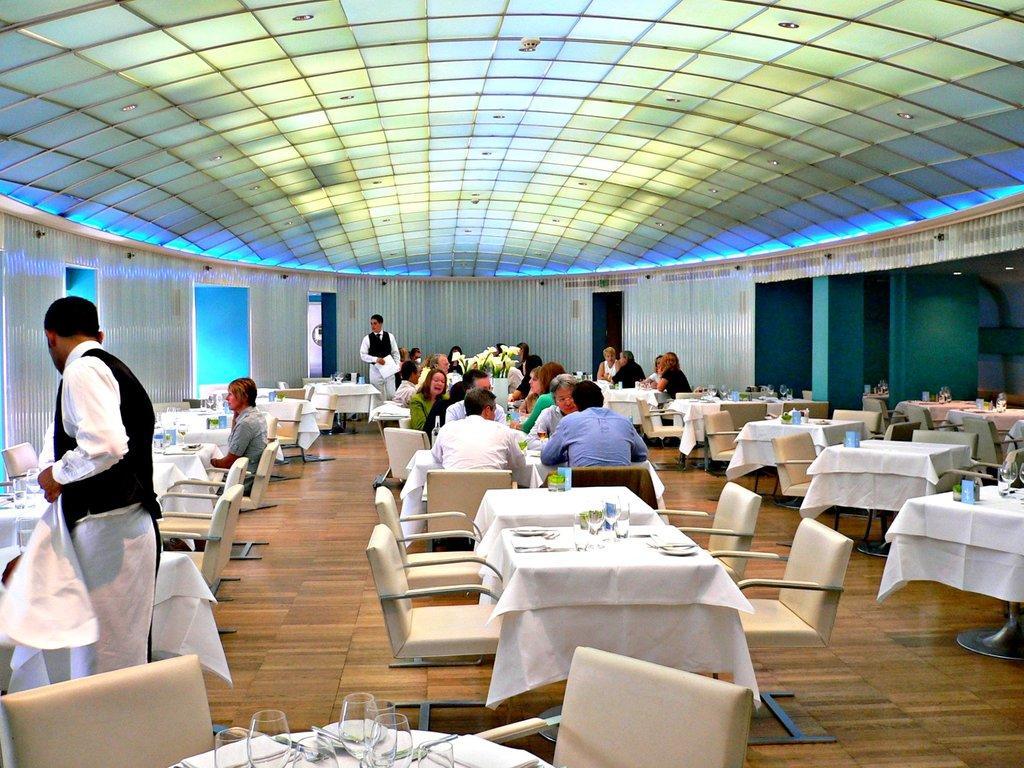Could you give a brief overview of what you see in this image? In this picture we can see a group of people some are sitting and some are standing and in front of them on table we can see plates, glasses, spoons, cloth and in background we can see wall, door. 